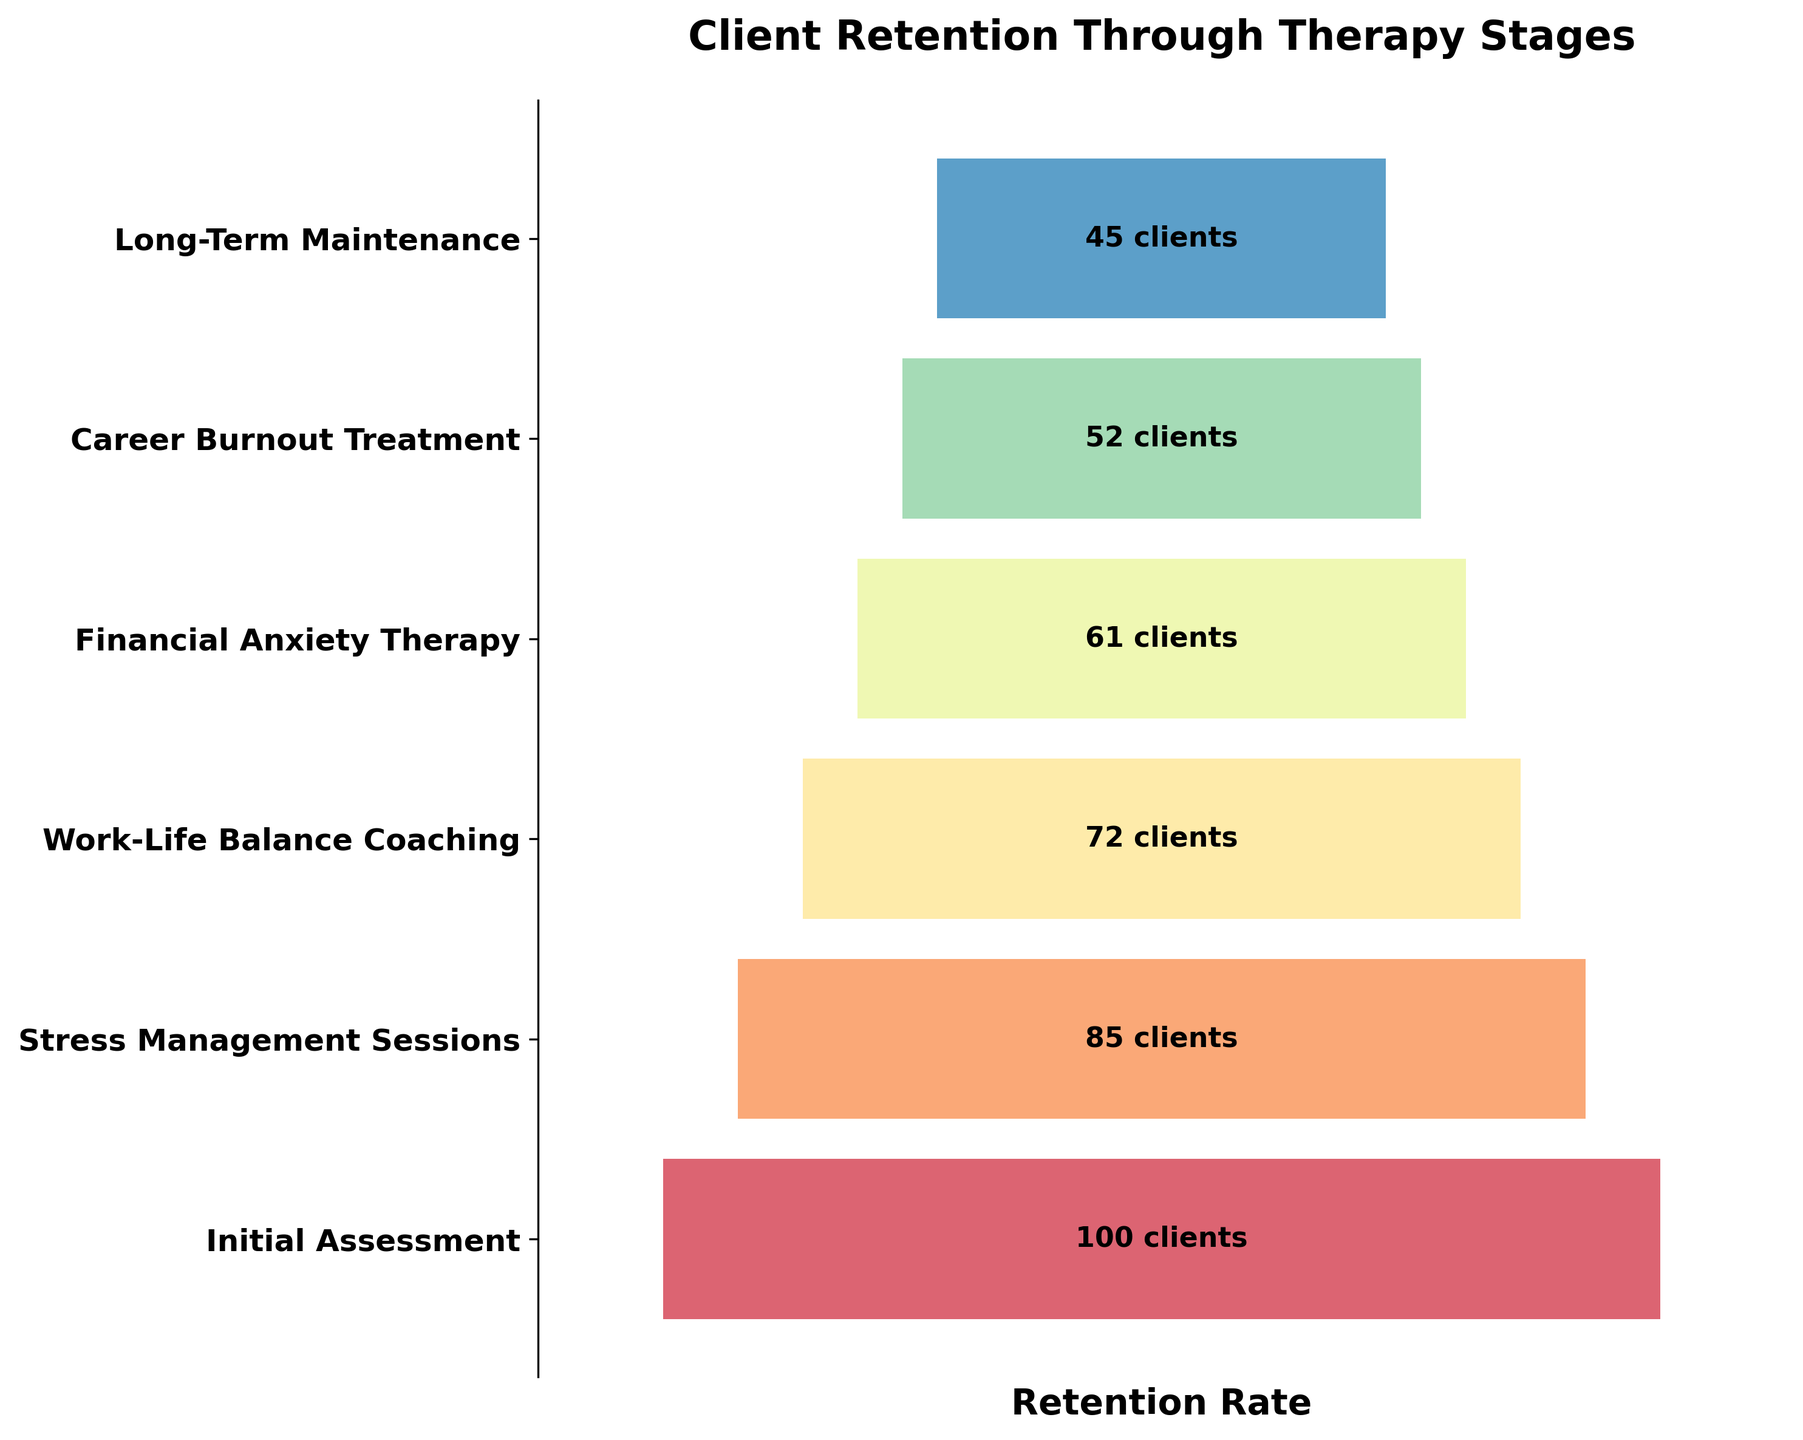Which stage has the highest number of retained clients? The initial assessment stage has the most retained clients as indicated by the widest bar that represents 100 clients.
Answer: Initial Assessment What's the difference in client retention between the Work-Life Balance Coaching stage and the Financial Anxiety Therapy stage? Work-Life Balance Coaching retains 72 clients, and Financial Anxiety Therapy retains 61 clients. The difference is 72 - 61.
Answer: 11 How many clients are retained at the Long-Term Maintenance stage? The bar representing Long-Term Maintenance stage has 45 clients as indicated by the text in the figure.
Answer: 45 Are more clients retained during the Stress Management Sessions stage or the Career Burnout Treatment stage? Stress Management Sessions retains 85 clients, and Career Burnout Treatment retains 52 clients, so more clients are retained during the Stress Management Sessions stage.
Answer: Stress Management Sessions What is the average number of clients retained from Financial Anxiety Therapy to Long-Term Maintenance? The retained clients for Financial Anxiety Therapy and Long-Term Maintenance are 61 and 45 respectively. The average is (61 + 45) / 2.
Answer: 53 Which stage sees the largest drop in client retention? Calculate the differences in client retention between each successive stage. The largest drop is between any two stages with the highest difference. Here the drop between Initial Assessment (100) and Stress Management Sessions (85) is 15, between Stress Management Sessions (85) and Work-Life Balance Coaching (72) is 13, between Work-Life Balance Coaching (72) and Financial Anxiety Therapy (61) is 11, between Financial Anxiety Therapy (61) and Career Burnout Treatment (52) is 9 and between Career Burnout Treatment (52) and Long-Term Maintenance (45) is 7. The largest drop is between Initial Assessment to Stress Management Sessions which is 15.
Answer: Initial Assessment to Stress Management Sessions By what percentage does client retention decrease from the Initial Assessment to Long-Term Maintenance? Initial Assessment retains 100 clients and Long-Term Maintenance retains 45 clients. The percentage decrease is ((100 - 45) / 100) * 100%.
Answer: 55% How many total clients are retained by the end of the Career Burnout Treatment stage? The number of clients retained at the end of the Career Burnout Treatment stage is shown in the figure as 52.
Answer: 52 Is the retention gap between any two stages larger than 15 clients? Comparing retention gaps between successive stages: Initial Assessment to Stress Management Sessions is 15, Stress Management Sessions to Work-Life Balance Coaching is 13, Work-Life Balance Coaching to Financial Anxiety Therapy is 11, Financial Anxiety Therapy to Career Burnout Treatment is 9, Career Burnout Treatment to Long-Term Maintenance is 7. None of these gaps exceed 15 clients.
Answer: No 